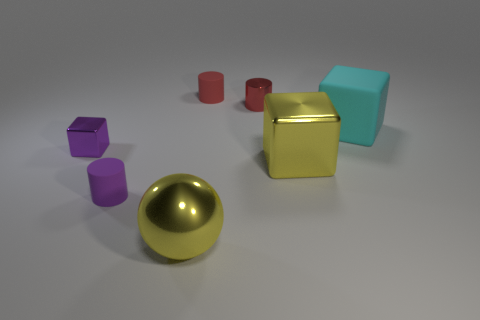Subtract all green spheres. Subtract all green cylinders. How many spheres are left? 1 Subtract all green blocks. How many yellow cylinders are left? 0 Add 5 tiny browns. How many things exist? 0 Subtract all large green metal blocks. Subtract all purple metal objects. How many objects are left? 6 Add 7 yellow metal balls. How many yellow metal balls are left? 8 Add 7 small purple metal cylinders. How many small purple metal cylinders exist? 7 Add 2 tiny cylinders. How many objects exist? 9 Subtract all yellow cubes. How many cubes are left? 2 Subtract all yellow blocks. How many blocks are left? 2 Subtract 0 brown balls. How many objects are left? 7 